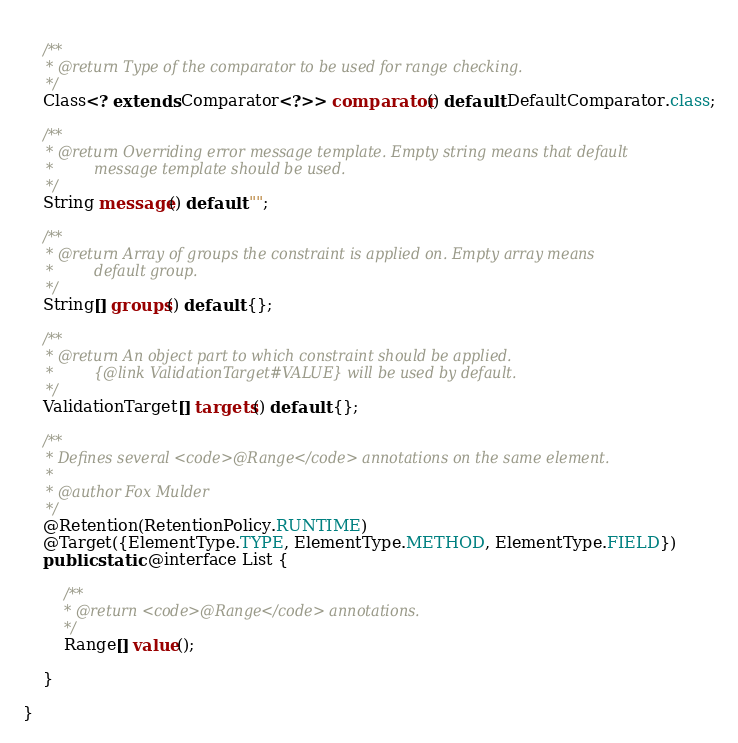<code> <loc_0><loc_0><loc_500><loc_500><_Java_>    
    /**
     * @return Type of the comparator to be used for range checking.
     */
    Class<? extends Comparator<?>> comparator() default DefaultComparator.class;
    
    /**
     * @return Overriding error message template. Empty string means that default
     *         message template should be used.
     */
    String message() default "";
    
    /**
     * @return Array of groups the constraint is applied on. Empty array means
     *         default group.
     */
    String[] groups() default {};
    
    /**
     * @return An object part to which constraint should be applied.
     *         {@link ValidationTarget#VALUE} will be used by default.
     */
    ValidationTarget[] targets() default {};
    
    /**
     * Defines several <code>@Range</code> annotations on the same element.
     * 
     * @author Fox Mulder
     */
    @Retention(RetentionPolicy.RUNTIME)
    @Target({ElementType.TYPE, ElementType.METHOD, ElementType.FIELD})
    public static @interface List {
        
        /**
         * @return <code>@Range</code> annotations.
         */
        Range[] value();
        
    }
    
}
</code> 